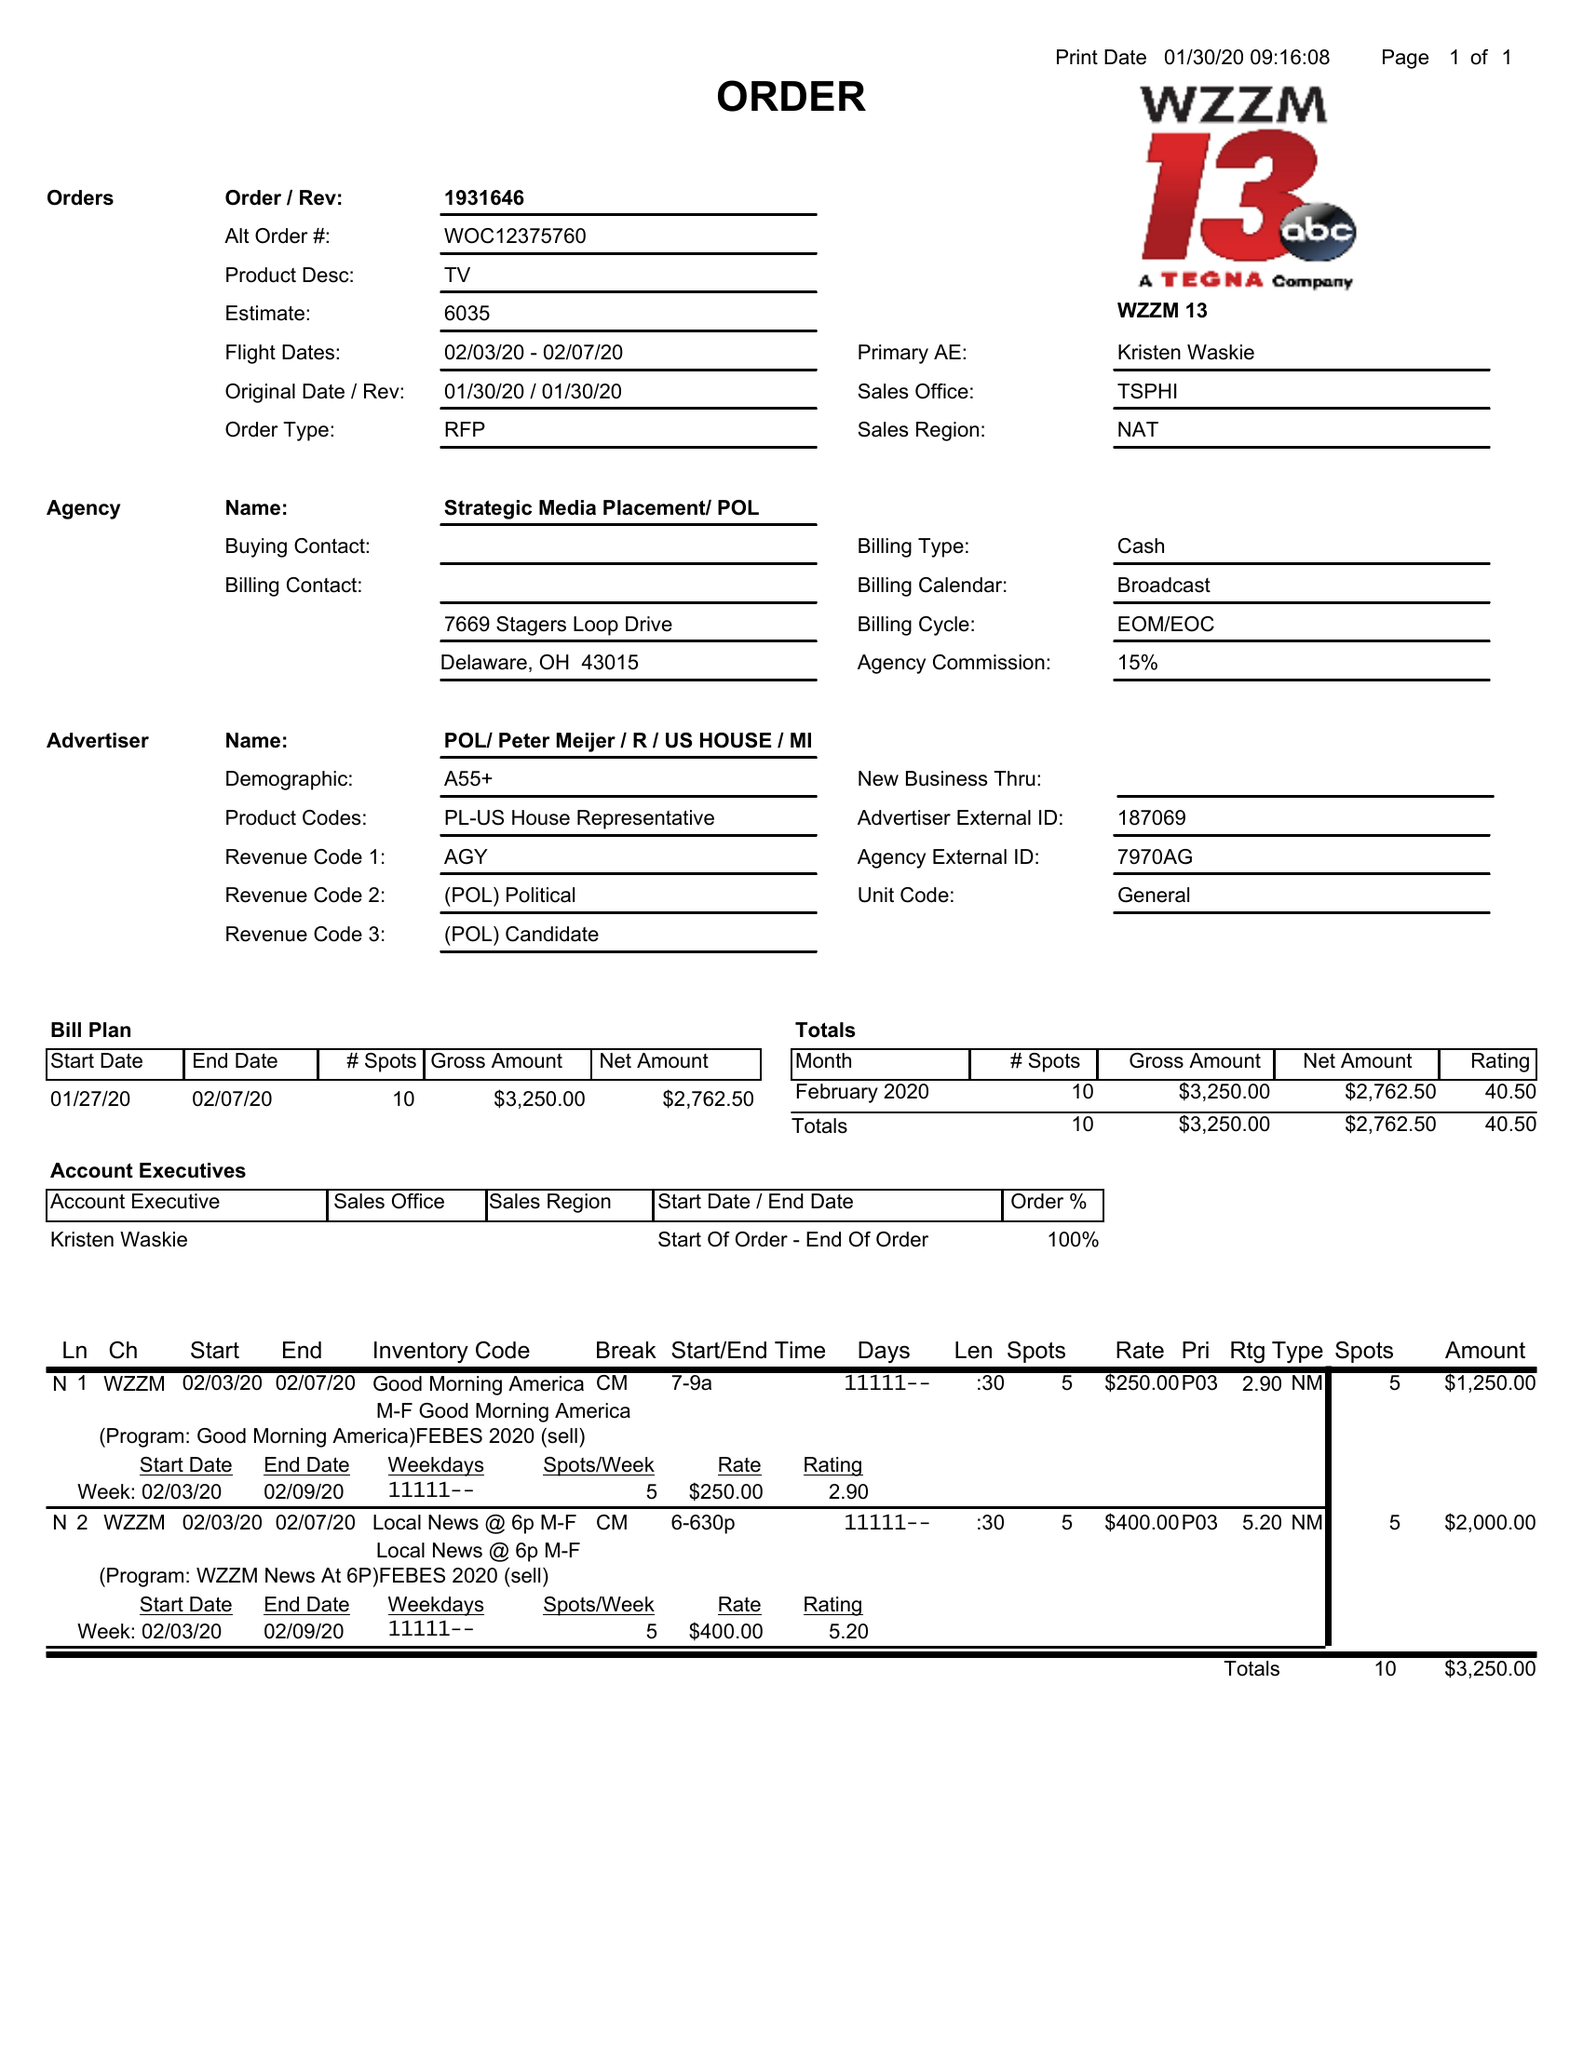What is the value for the advertiser?
Answer the question using a single word or phrase. POL/PETERMEIJER/R/USHOUSE/MI 